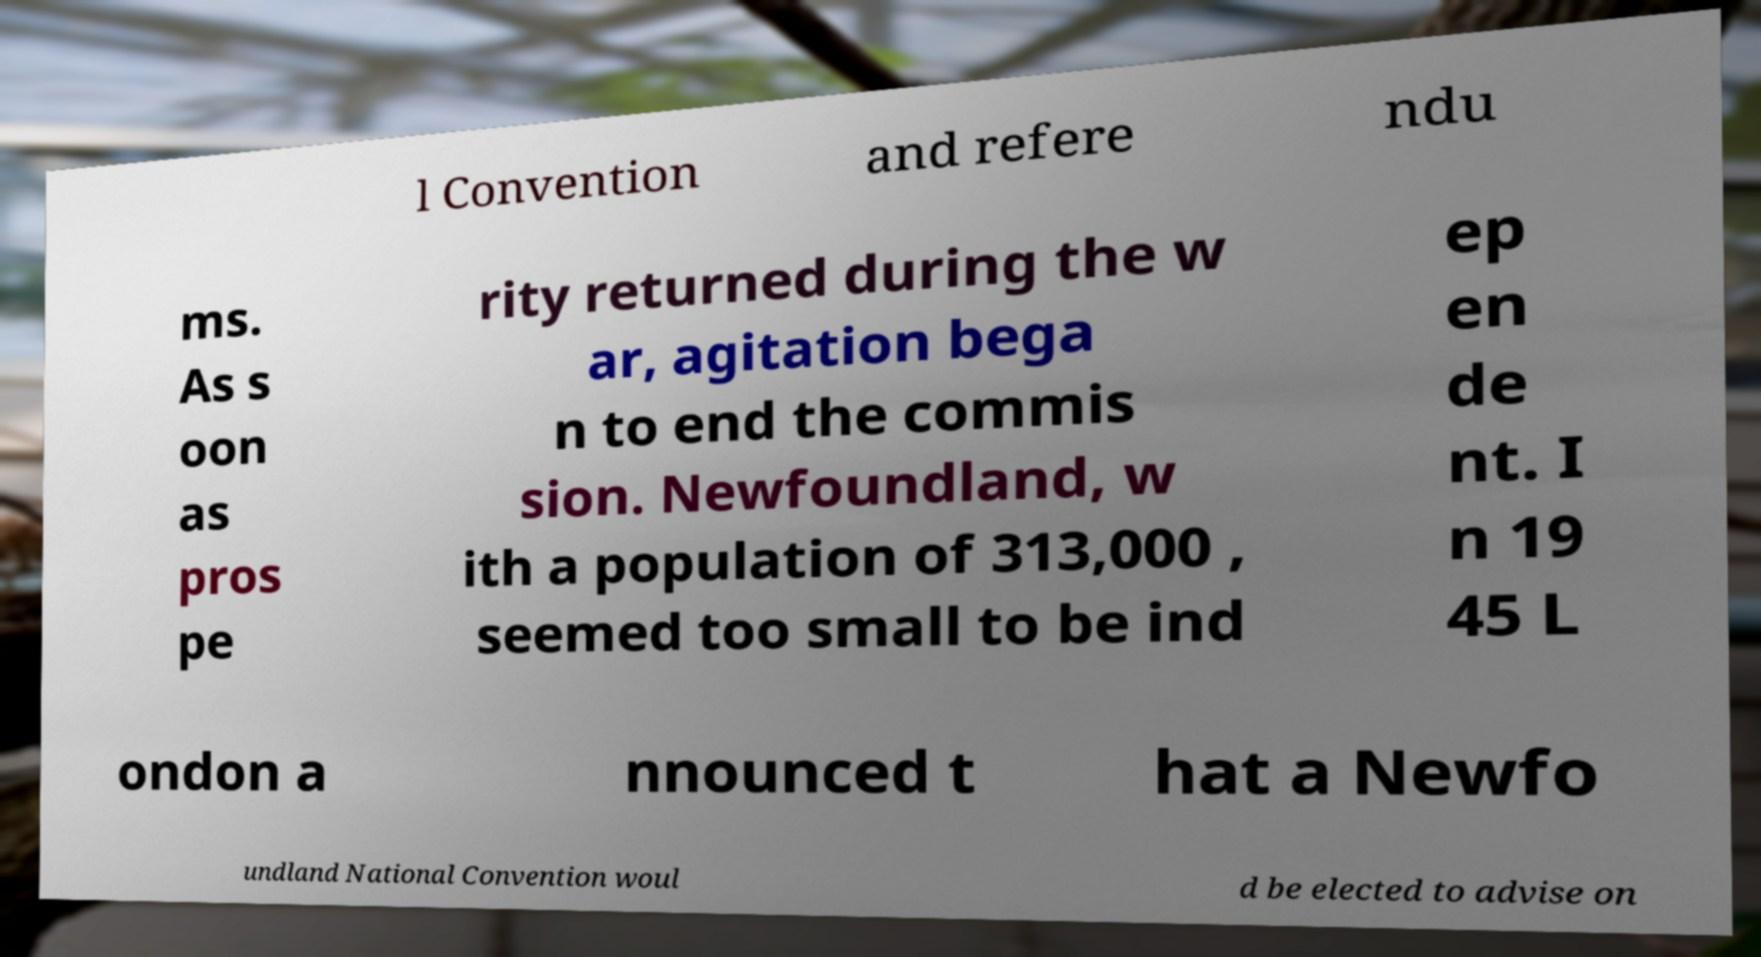Could you assist in decoding the text presented in this image and type it out clearly? l Convention and refere ndu ms. As s oon as pros pe rity returned during the w ar, agitation bega n to end the commis sion. Newfoundland, w ith a population of 313,000 , seemed too small to be ind ep en de nt. I n 19 45 L ondon a nnounced t hat a Newfo undland National Convention woul d be elected to advise on 